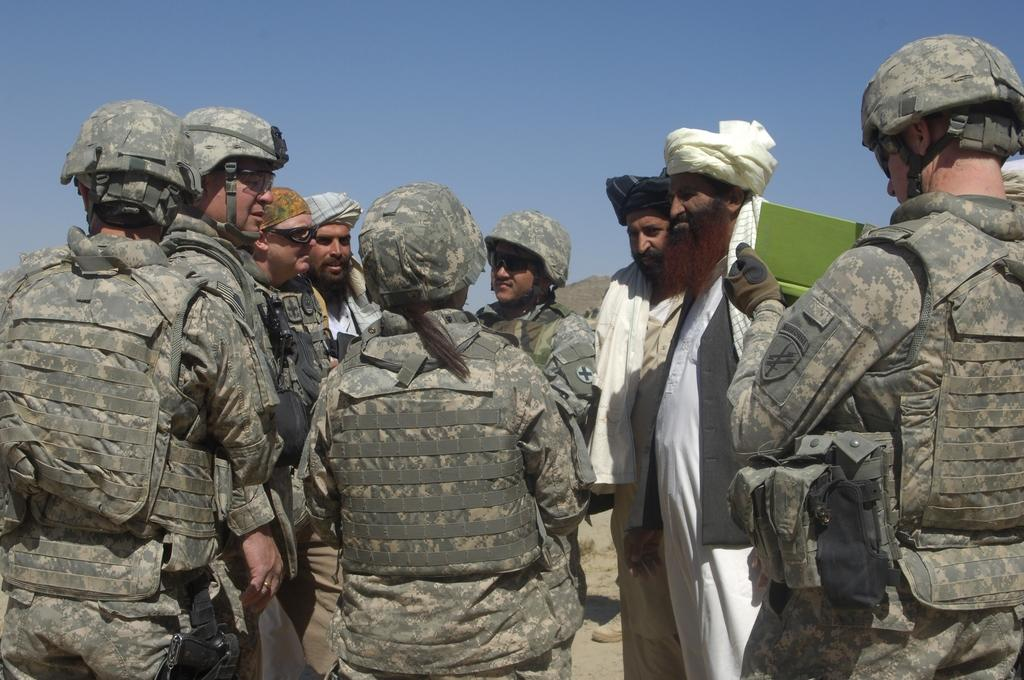How many people are in the image? There is a group of people in the image. What is one person doing with their hands? One person is holding a book with their hands. What can be seen in the background of the image? There is sky visible in the background of the image. Can you see any toads swimming in the image? There are no toads or swimming activity present in the image. 